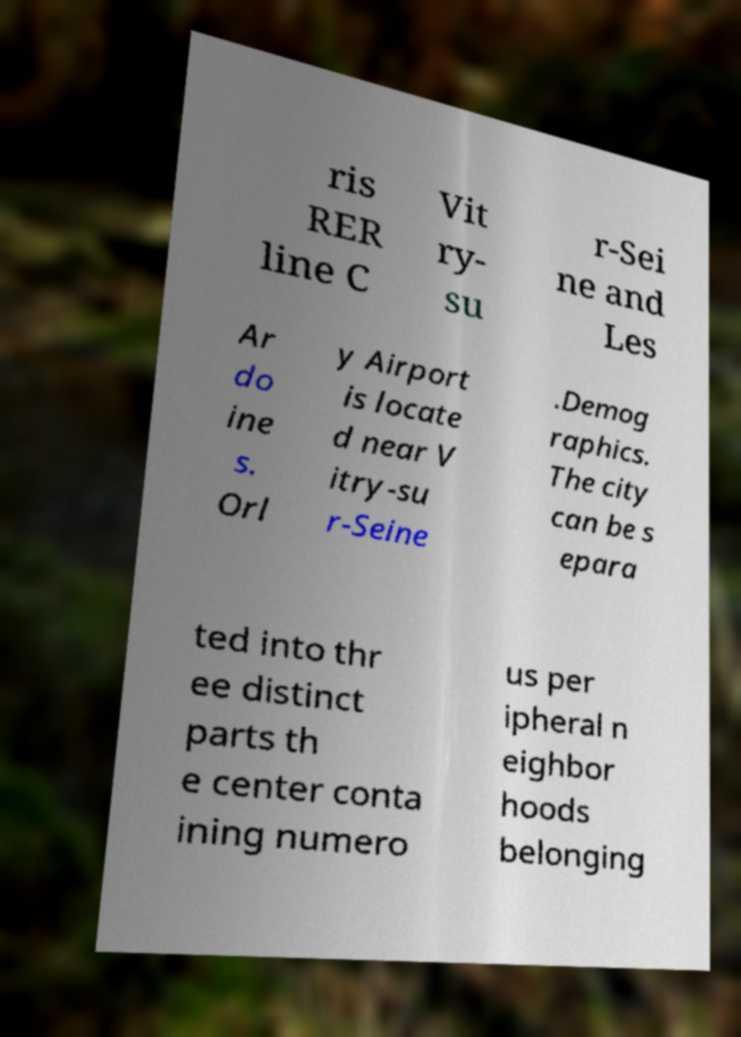There's text embedded in this image that I need extracted. Can you transcribe it verbatim? ris RER line C Vit ry- su r-Sei ne and Les Ar do ine s. Orl y Airport is locate d near V itry-su r-Seine .Demog raphics. The city can be s epara ted into thr ee distinct parts th e center conta ining numero us per ipheral n eighbor hoods belonging 